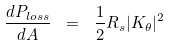<formula> <loc_0><loc_0><loc_500><loc_500>\frac { d P _ { l o s s } } { d A } \ = \ \frac { 1 } { 2 } R _ { s } | K _ { \theta } | ^ { 2 }</formula> 